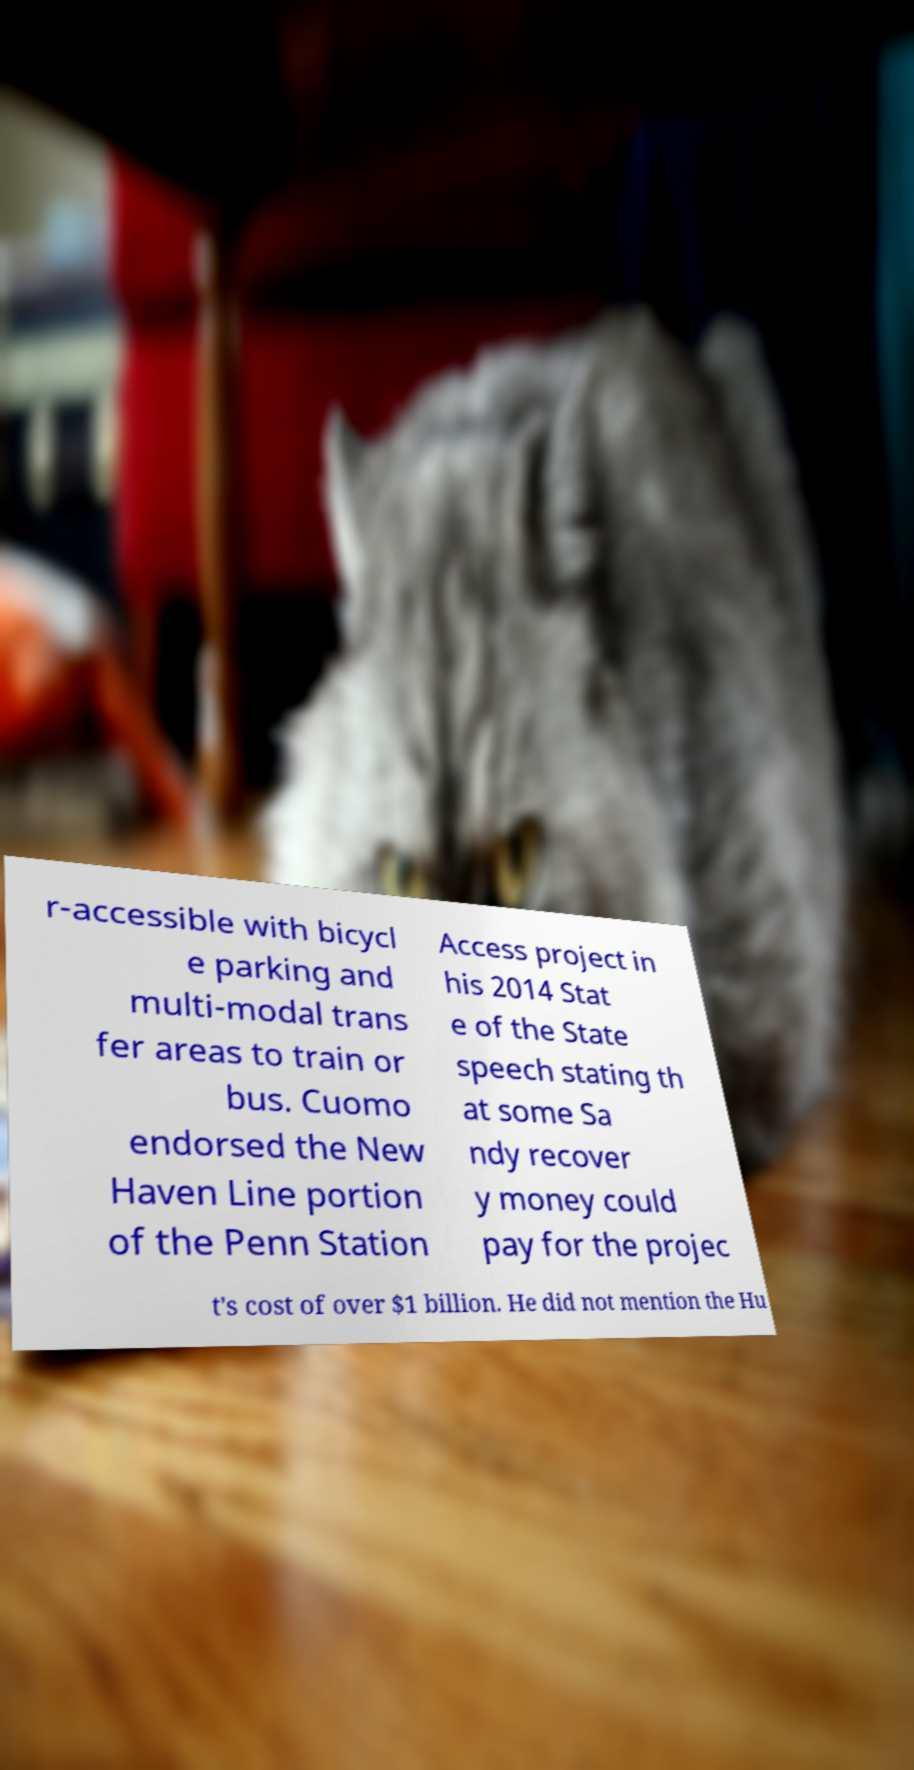Please read and relay the text visible in this image. What does it say? r-accessible with bicycl e parking and multi-modal trans fer areas to train or bus. Cuomo endorsed the New Haven Line portion of the Penn Station Access project in his 2014 Stat e of the State speech stating th at some Sa ndy recover y money could pay for the projec t's cost of over $1 billion. He did not mention the Hu 